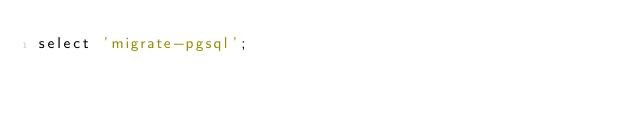<code> <loc_0><loc_0><loc_500><loc_500><_SQL_>select 'migrate-pgsql';
</code> 